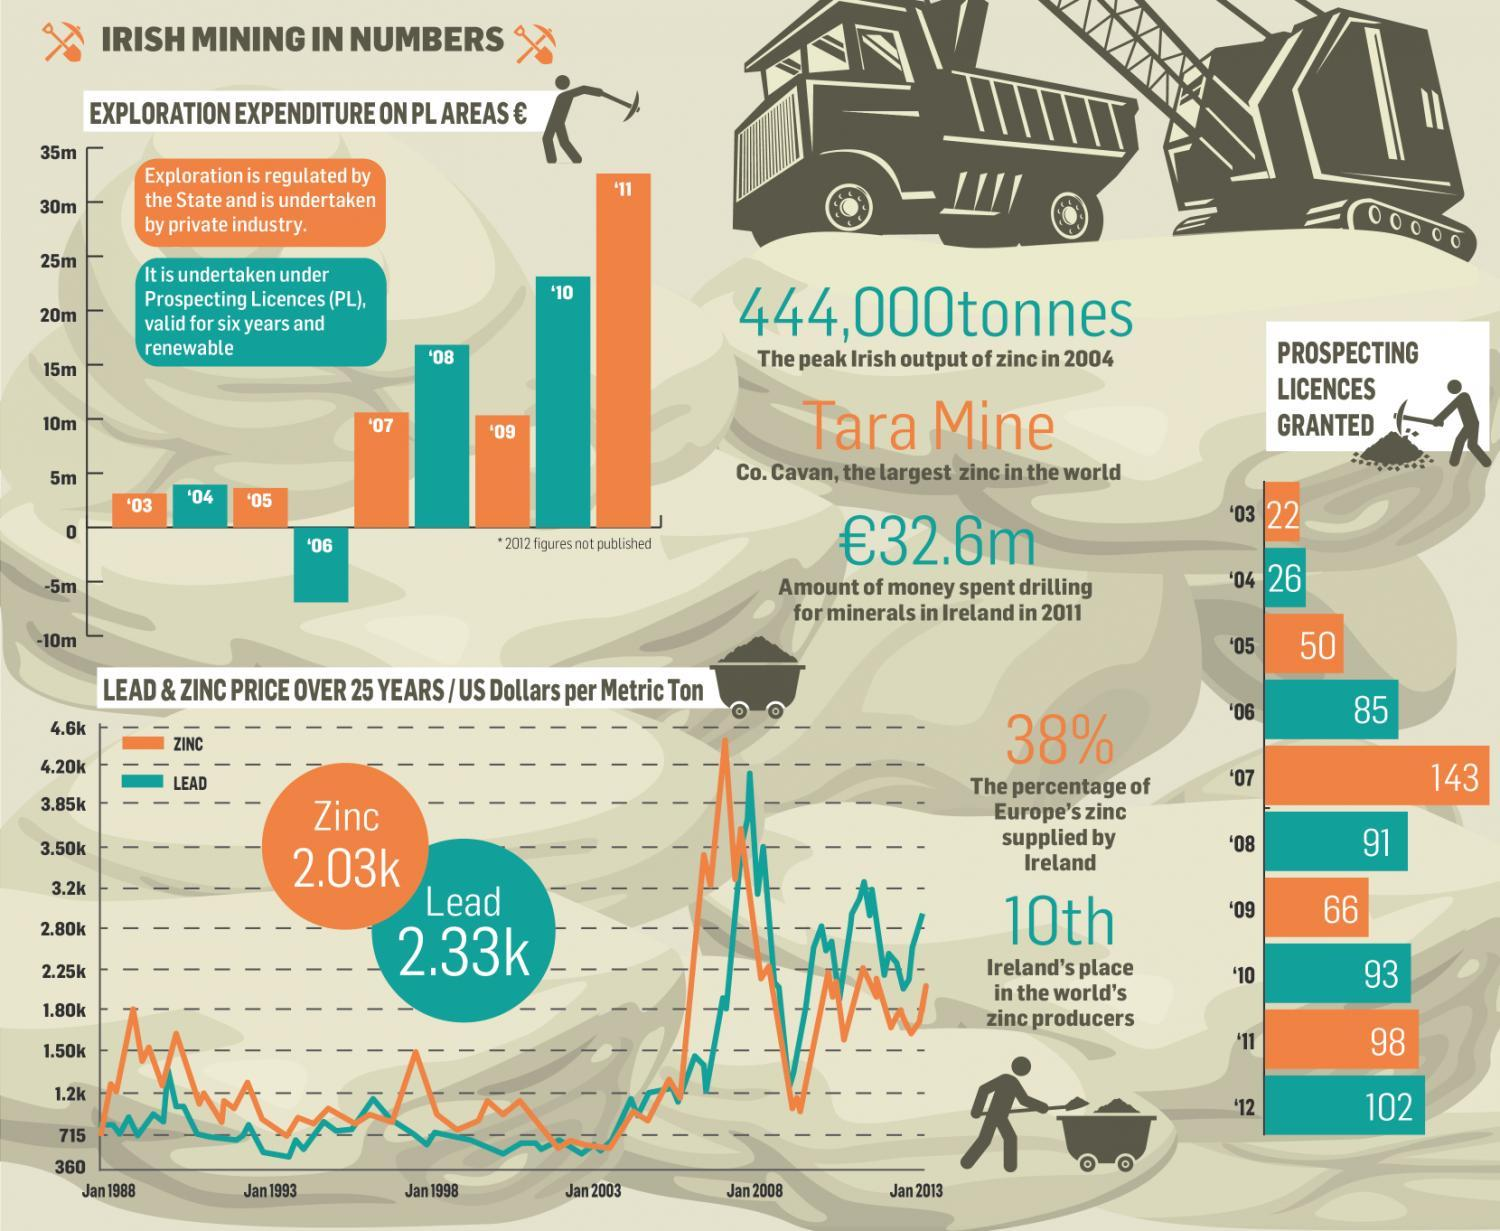What is the percentage of zinc supplied to Europe, not by Ireland?
Answer the question with a short phrase. 62% Which color is used to represent zinc-blue, orange, or green? orange 